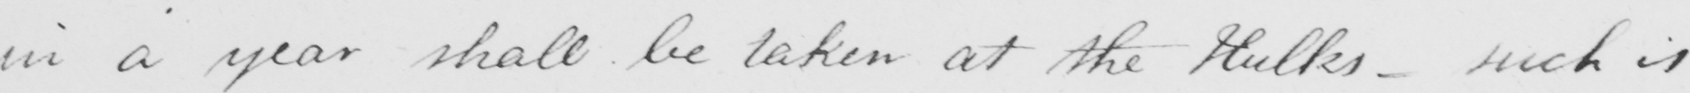Please transcribe the handwritten text in this image. in a year shall be taken at the Hulks- such is 